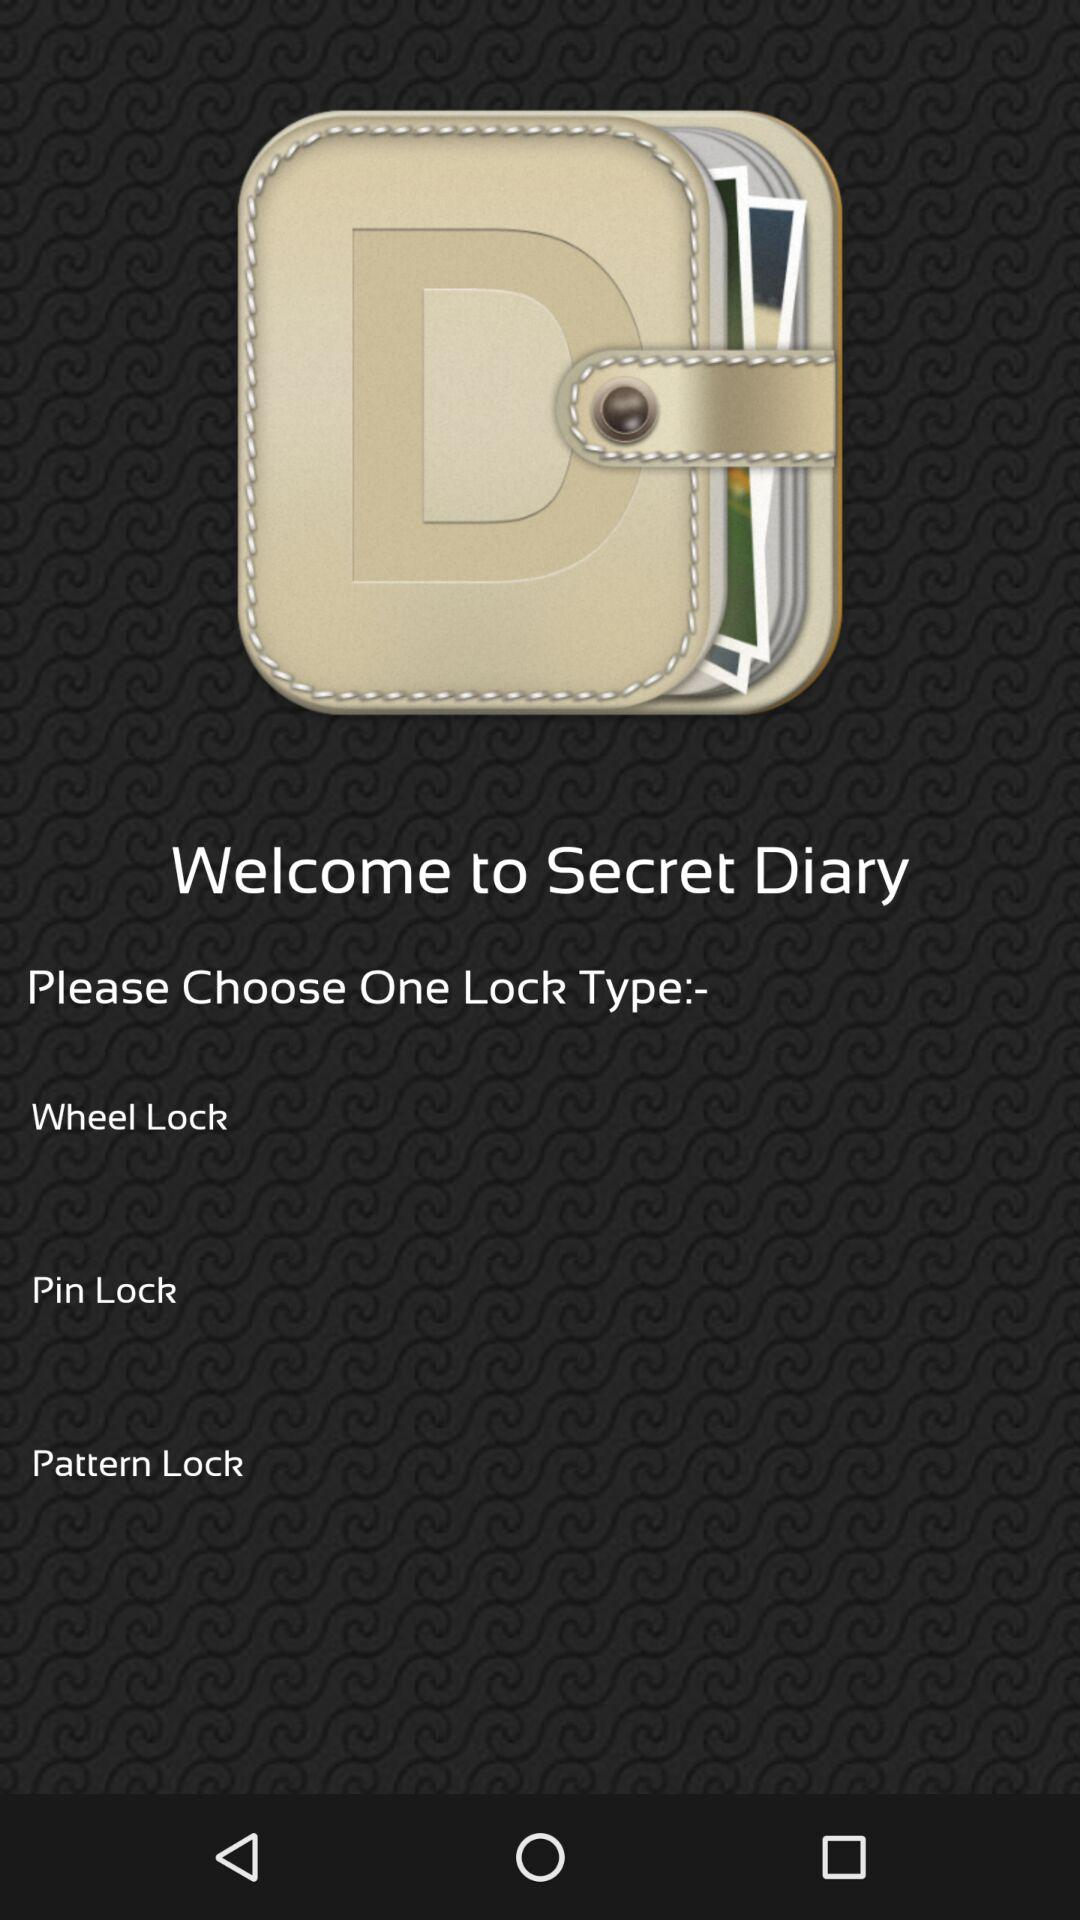What are the given lock type options? The given lock type options are "Wheel Lock", "Pin Lock" and "Pattern Lock". 